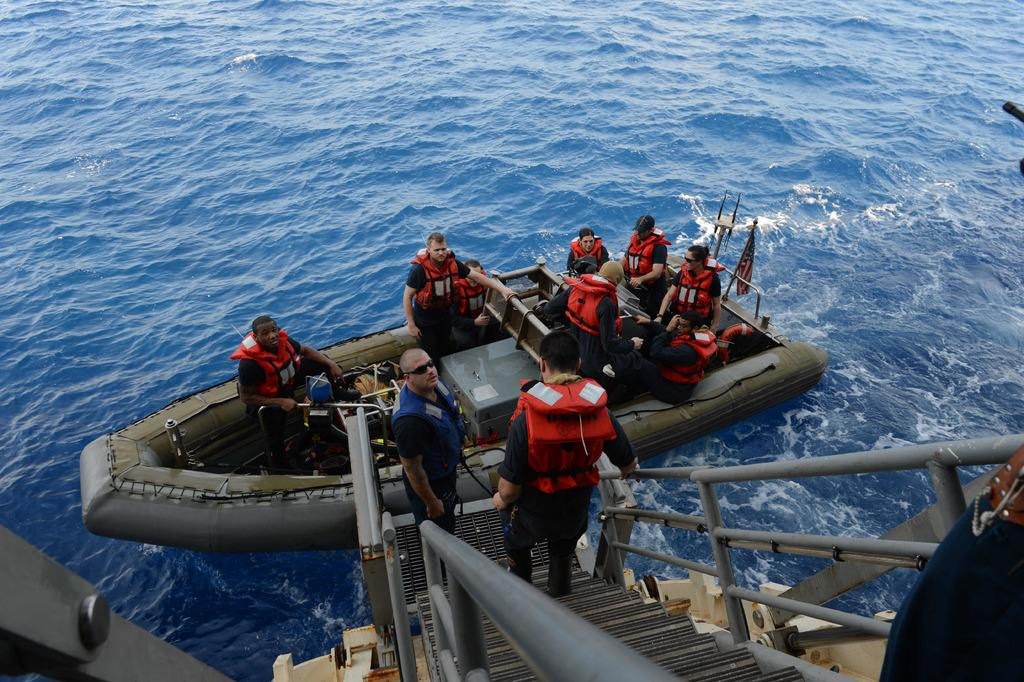What activity are the people in the image engaged in? There is a group of people in a boat in the image. How many people are on the steps in the image? There are three persons on the steps in the image. What material are the rods visible in the image made of? Metal rods are visible in the image. What is the primary substance surrounding the boat and steps? Water is present in the image. What type of environment might the image have been taken in? The image may have been taken been taken in the ocean. Can you see a ball being thrown by one of the people in the image? There is no ball present in the image; it only features a group of people in a boat, three persons on the steps, metal rods, water, and possibly an oceanic environment. 